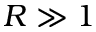Convert formula to latex. <formula><loc_0><loc_0><loc_500><loc_500>R \gg 1</formula> 